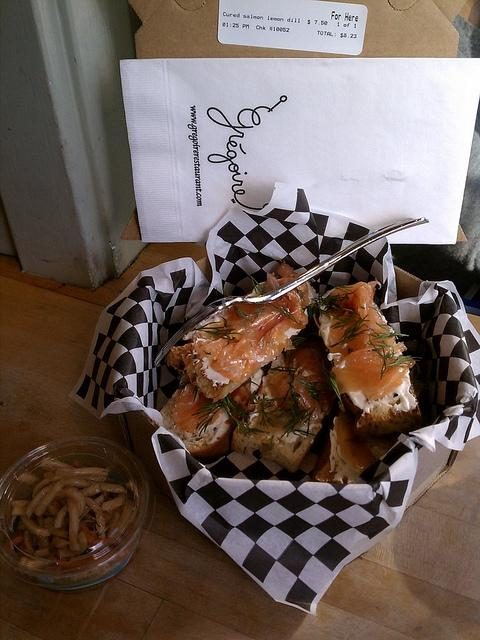The basket of salmon is currently being eaten at which location? Please explain your reasoning. restaurant. It is plated like a paid eatery. 